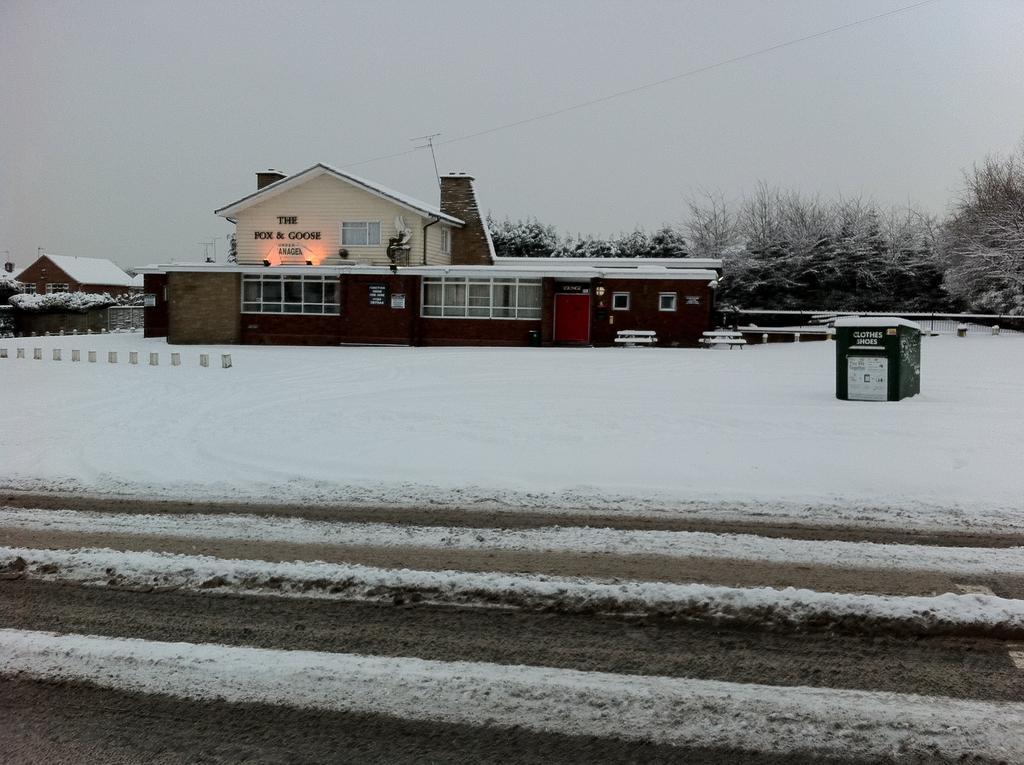Please provide a concise description of this image. In this picture we can see snow at the bottom, in the background there are houses, on the right side we can see trees, there is a box in the middle, we can see the sky at the top of the picture. 